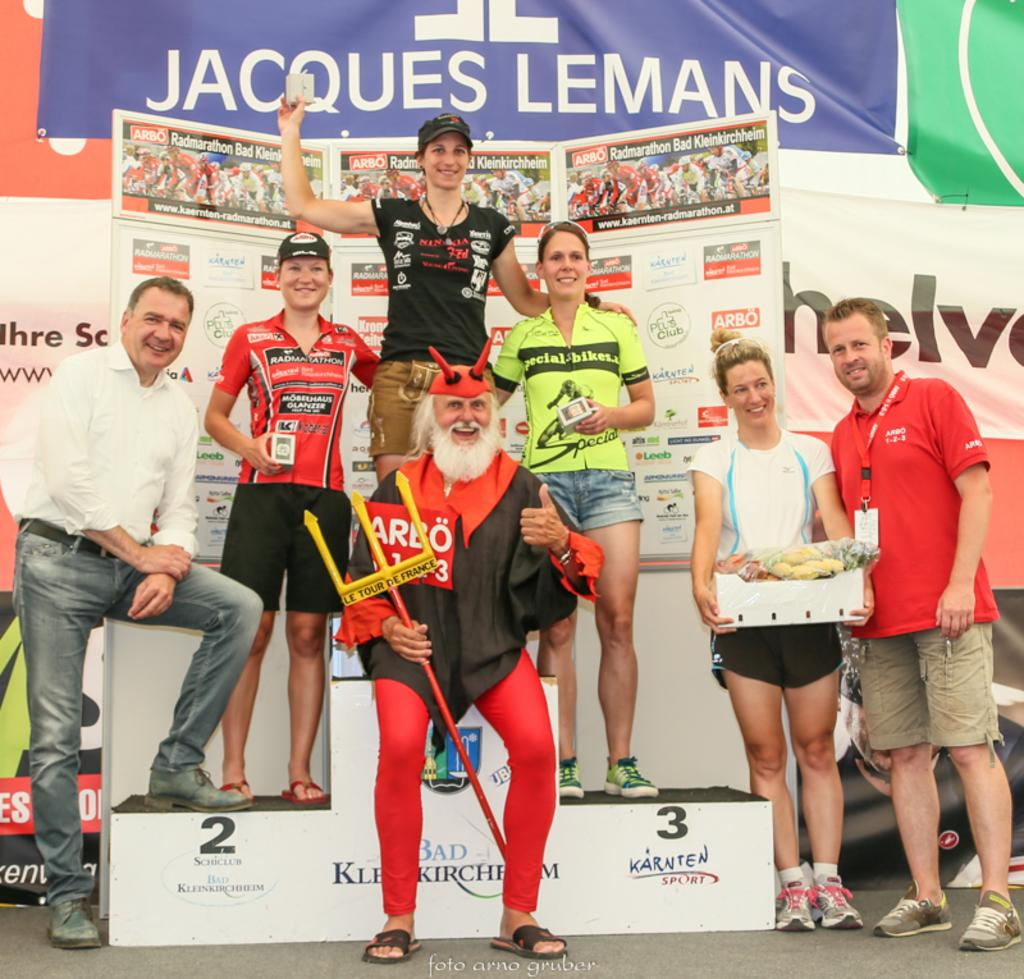<image>
Give a short and clear explanation of the subsequent image. Several people stand on a winner's pedestal in front of a Jacques Lemans sign. 